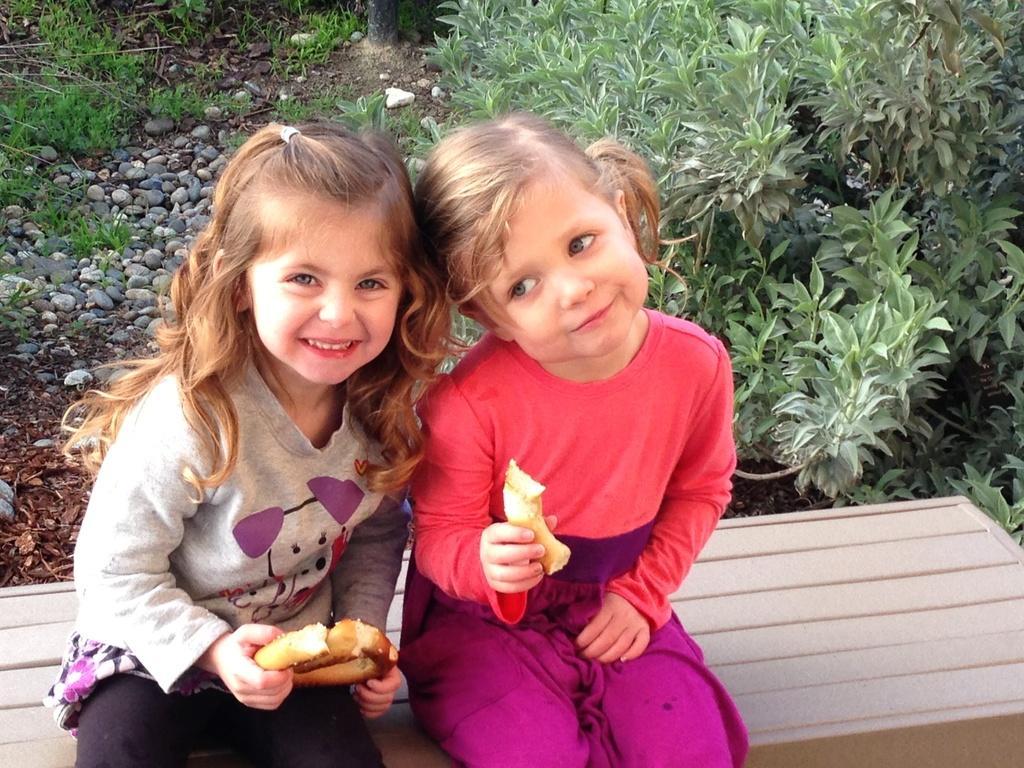Describe this image in one or two sentences. In the middle a girl is sitting, she wore red color t-shirt and holding a food item in her right hand. Beside her another girl is sitting, she wore grey color t-shirt and smiling. Behind them there are plants. 